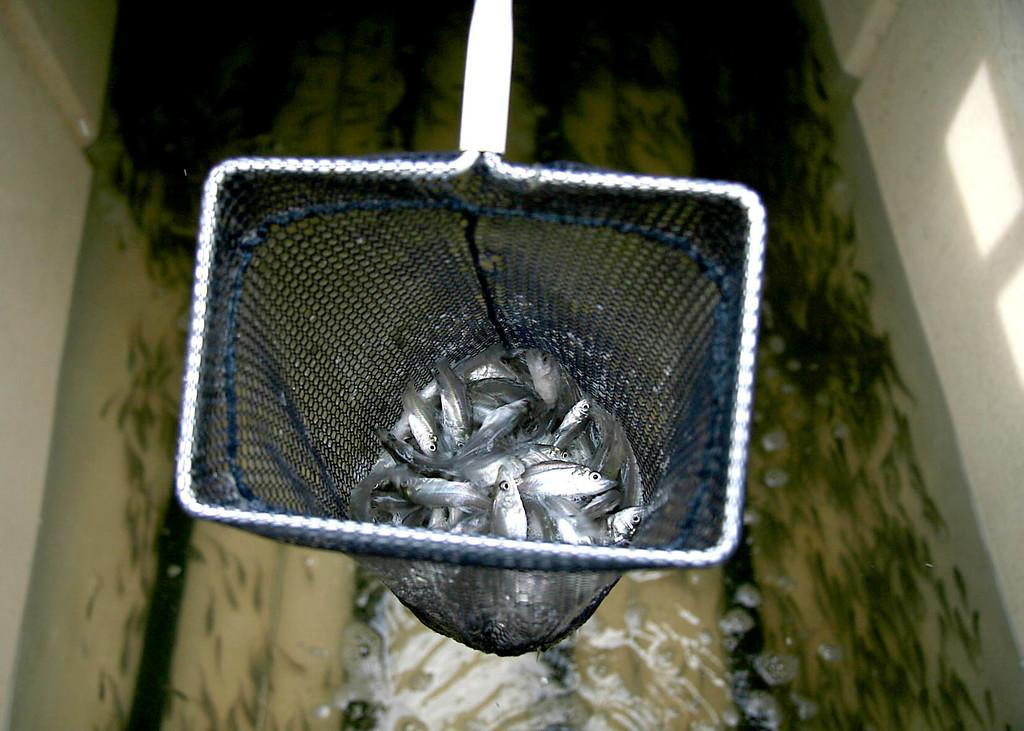What is being held in the scoop net in the image? There are fishes in a scoop net in the image. What is the location of the other fishes in the image? There are fishes in the water under the scoop net. What can be seen on the sides of the image? There are walls on the left and right sides of the image. What type of music can be heard playing in the background of the image? There is no music present in the image, as it focuses on fishes and a scoop net. 